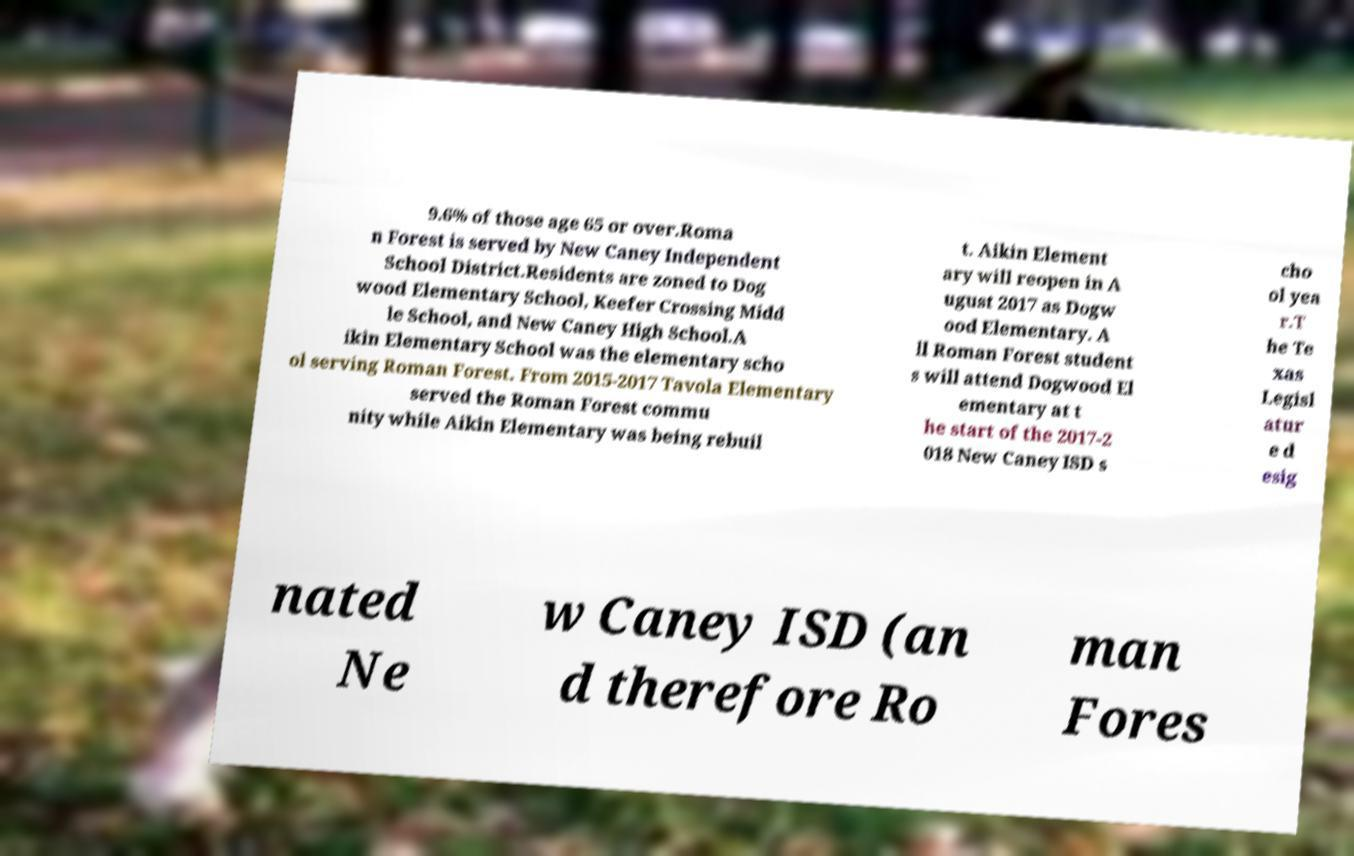Please read and relay the text visible in this image. What does it say? 9.6% of those age 65 or over.Roma n Forest is served by New Caney Independent School District.Residents are zoned to Dog wood Elementary School, Keefer Crossing Midd le School, and New Caney High School.A ikin Elementary School was the elementary scho ol serving Roman Forest. From 2015-2017 Tavola Elementary served the Roman Forest commu nity while Aikin Elementary was being rebuil t. Aikin Element ary will reopen in A ugust 2017 as Dogw ood Elementary. A ll Roman Forest student s will attend Dogwood El ementary at t he start of the 2017-2 018 New Caney ISD s cho ol yea r.T he Te xas Legisl atur e d esig nated Ne w Caney ISD (an d therefore Ro man Fores 